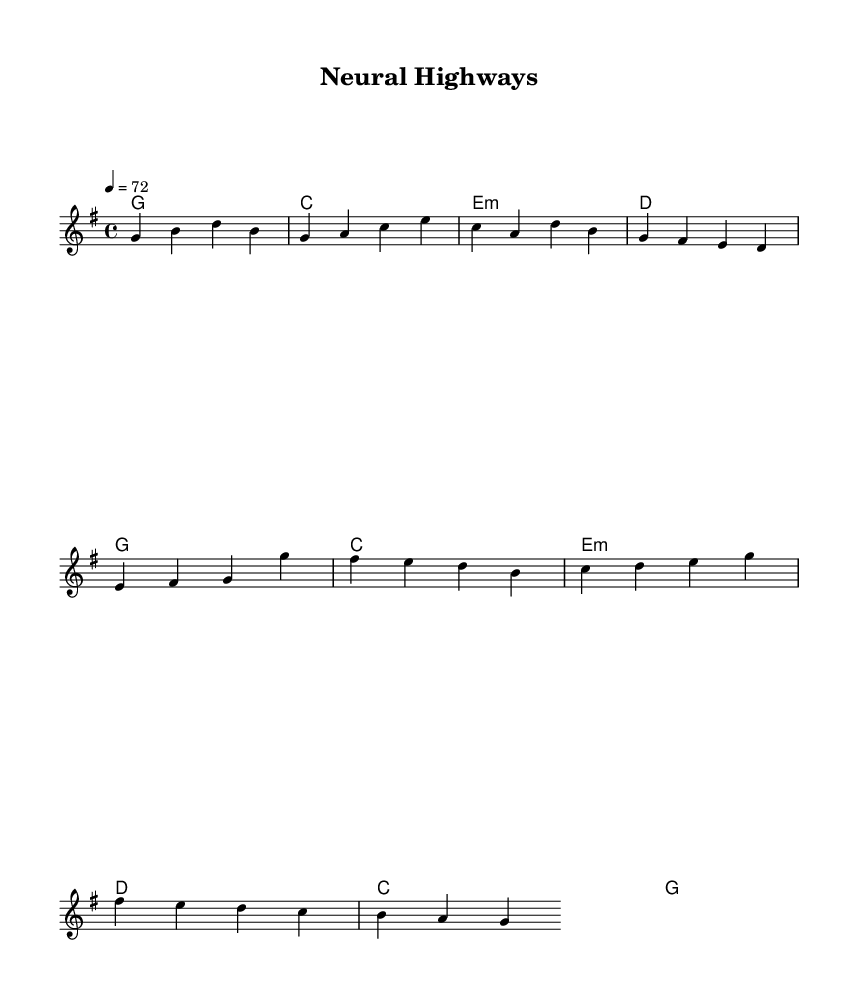What is the key signature of this music? The key signature is G major, which has one sharp (F#). It is indicated at the beginning of the staff, which specifies the pitches of the notes used throughout the piece.
Answer: G major What is the time signature of the piece? The time signature is 4/4, shown at the beginning of the score. This indicates that each measure has four beats, and each quarter note receives one beat.
Answer: 4/4 What is the tempo marking for this composition? The tempo marking indicates a speed of 72 beats per minute. This is specified in the tempo directive at the beginning of the score, stating how fast the music should be played.
Answer: 72 How many measures are in the verse section? The verse section consists of four measures, which can be counted by looking at the sequences of the notes and their groupings in the melody part.
Answer: 4 What are the final lyrics sung in the chorus? The final lyrics of the chorus are "high ways of mine," which can be traced in the lyrics section under the chorus portion of the score.
Answer: high ways of mine What type of chords are primarily used in this piece? The chords used throughout this piece are primarily major and minor triads, indicated in the harmonies part. This is a characteristic feature of country rock music, reflecting its emotive and straightforward harmonic structure.
Answer: major and minor triads What does the song's theme focus on according to the lyrics? The song's theme revolves around introspection and memory, delving into the processes of memory formation and recall as conveyed through the lyrical content. This connection can be derived from phrases like "memories taking shape" that appear in the lyrics.
Answer: introspection and memory 